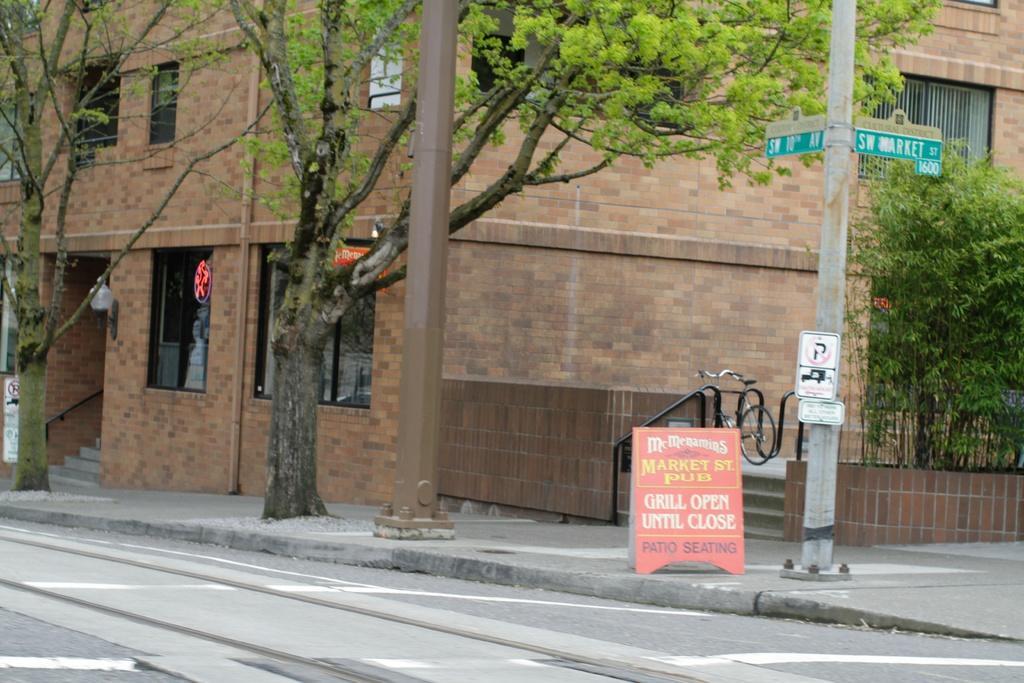Please provide a concise description of this image. In this image, we can see a building with walls, windows and grill. Here we can see few stairs, rods, pipe. In the middle of the image, we can see there are so many trees, poles, posters, rods, bicycle, sign boards, boards. At the bottom, there is a road. 